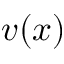<formula> <loc_0><loc_0><loc_500><loc_500>{ v } ( { x } )</formula> 